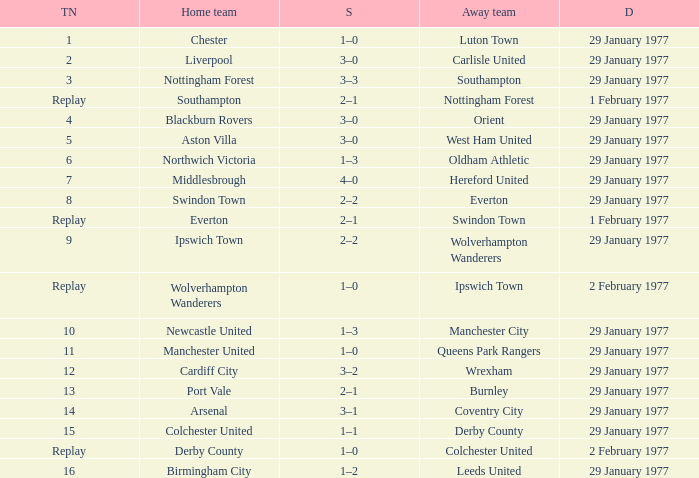What is the tie number when the home team is Port Vale? 13.0. 